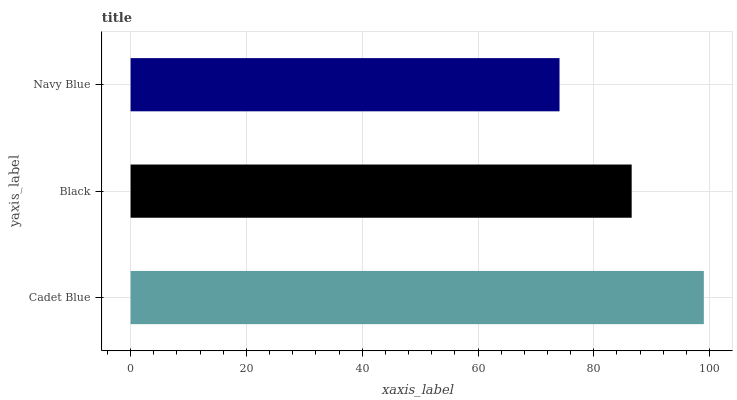Is Navy Blue the minimum?
Answer yes or no. Yes. Is Cadet Blue the maximum?
Answer yes or no. Yes. Is Black the minimum?
Answer yes or no. No. Is Black the maximum?
Answer yes or no. No. Is Cadet Blue greater than Black?
Answer yes or no. Yes. Is Black less than Cadet Blue?
Answer yes or no. Yes. Is Black greater than Cadet Blue?
Answer yes or no. No. Is Cadet Blue less than Black?
Answer yes or no. No. Is Black the high median?
Answer yes or no. Yes. Is Black the low median?
Answer yes or no. Yes. Is Cadet Blue the high median?
Answer yes or no. No. Is Cadet Blue the low median?
Answer yes or no. No. 